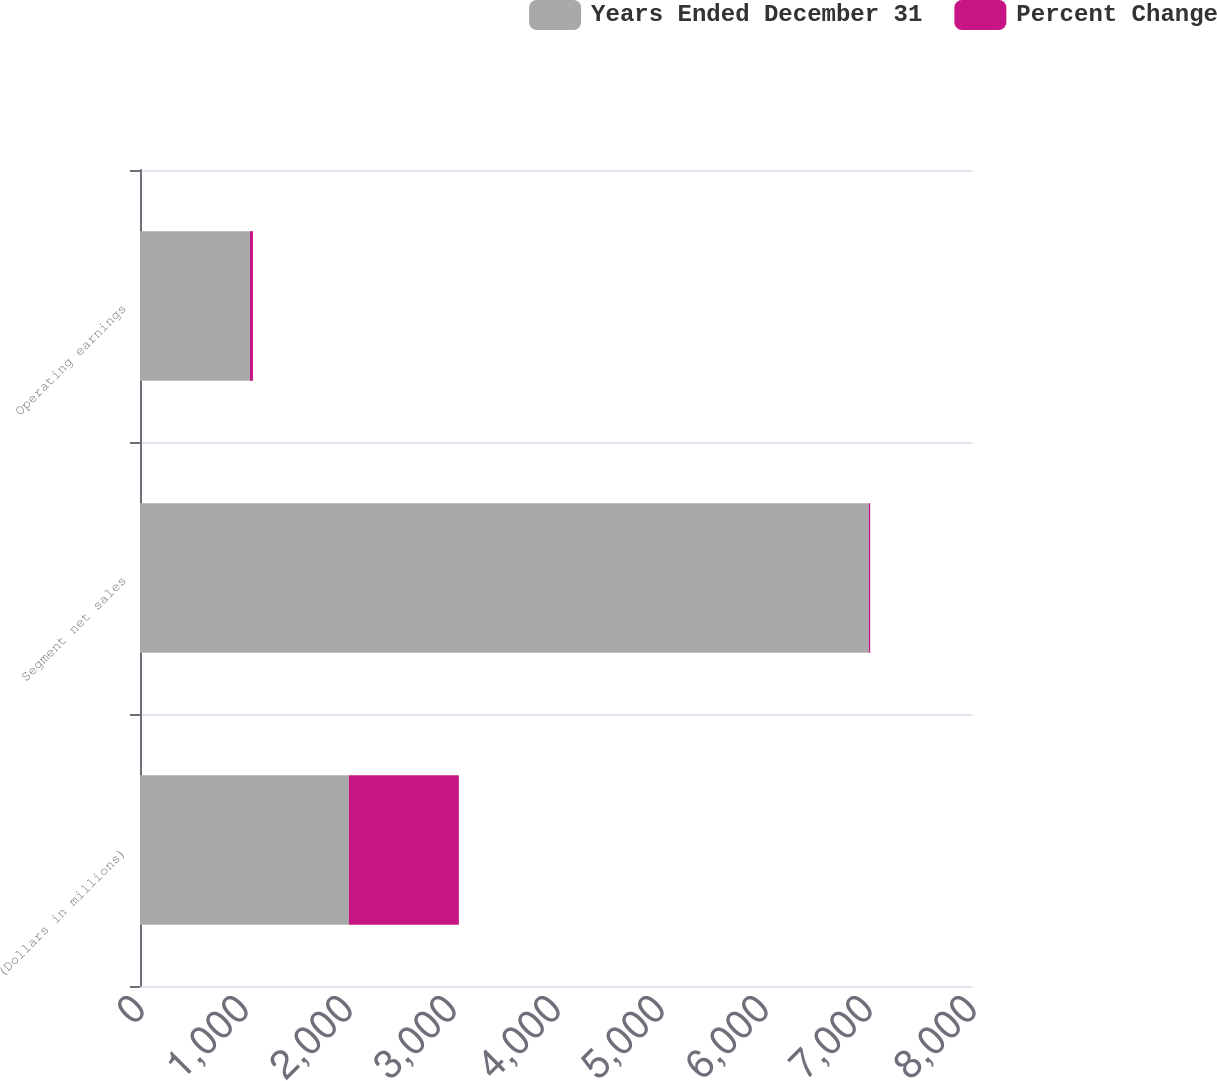<chart> <loc_0><loc_0><loc_500><loc_500><stacked_bar_chart><ecel><fcel>(Dollars in millions)<fcel>Segment net sales<fcel>Operating earnings<nl><fcel>Years Ended December 31<fcel>2009<fcel>7008<fcel>1057<nl><fcel>Percent Change<fcel>1057<fcel>13<fcel>29<nl></chart> 